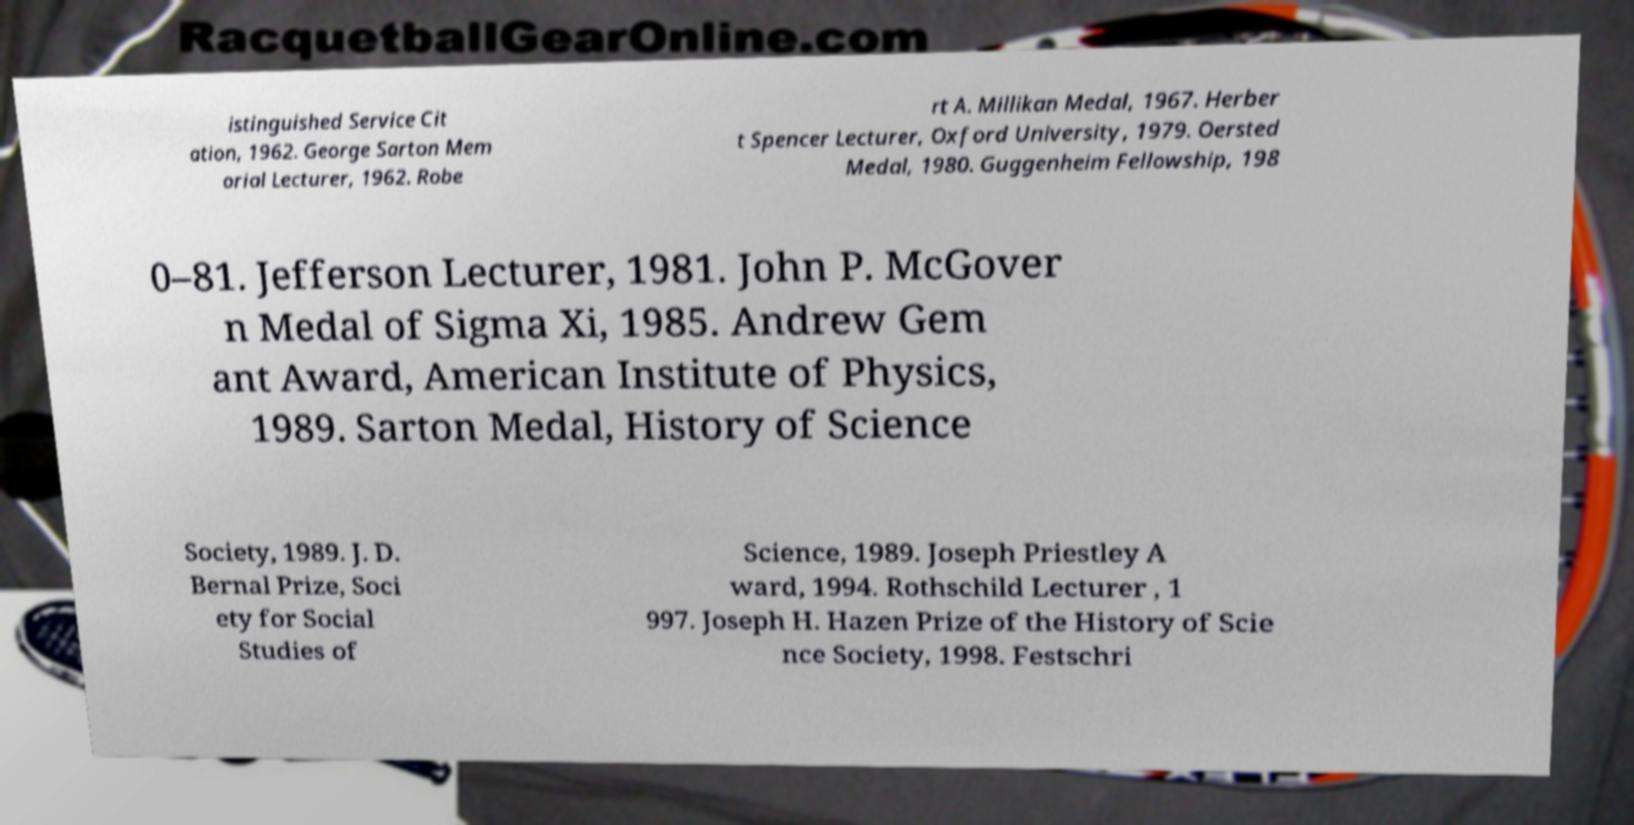Could you assist in decoding the text presented in this image and type it out clearly? istinguished Service Cit ation, 1962. George Sarton Mem orial Lecturer, 1962. Robe rt A. Millikan Medal, 1967. Herber t Spencer Lecturer, Oxford University, 1979. Oersted Medal, 1980. Guggenheim Fellowship, 198 0–81. Jefferson Lecturer, 1981. John P. McGover n Medal of Sigma Xi, 1985. Andrew Gem ant Award, American Institute of Physics, 1989. Sarton Medal, History of Science Society, 1989. J. D. Bernal Prize, Soci ety for Social Studies of Science, 1989. Joseph Priestley A ward, 1994. Rothschild Lecturer , 1 997. Joseph H. Hazen Prize of the History of Scie nce Society, 1998. Festschri 